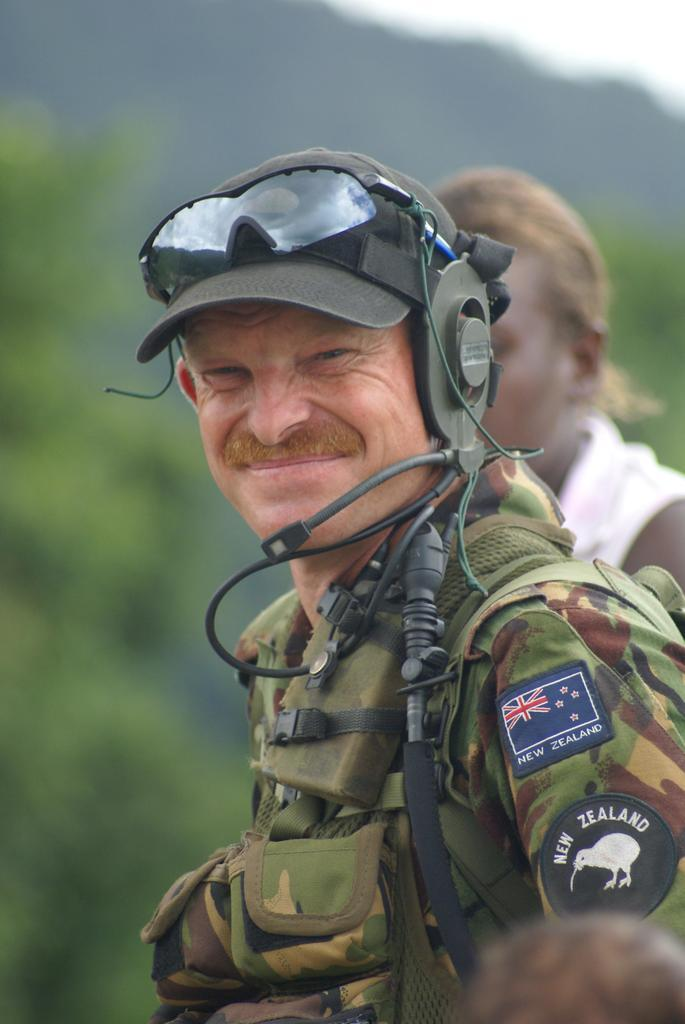What is the main subject of the image? There is a man standing in the middle of the image. What is the man doing in the image? The man is smiling in the image. Can you describe the person standing behind the man? There is another person standing behind the man in the image. What can be seen in the background of the image? Trees are visible in the background of the image. How would you describe the background of the image? The background of the image is blurred. What type of joke is the man telling to his sisters in the image? There is no indication in the image that the man is telling a joke or that he has any sisters present. 